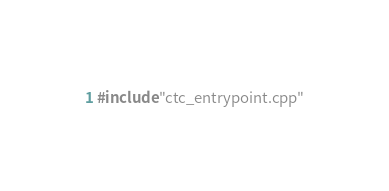<code> <loc_0><loc_0><loc_500><loc_500><_Cuda_>#include "ctc_entrypoint.cpp"
</code> 